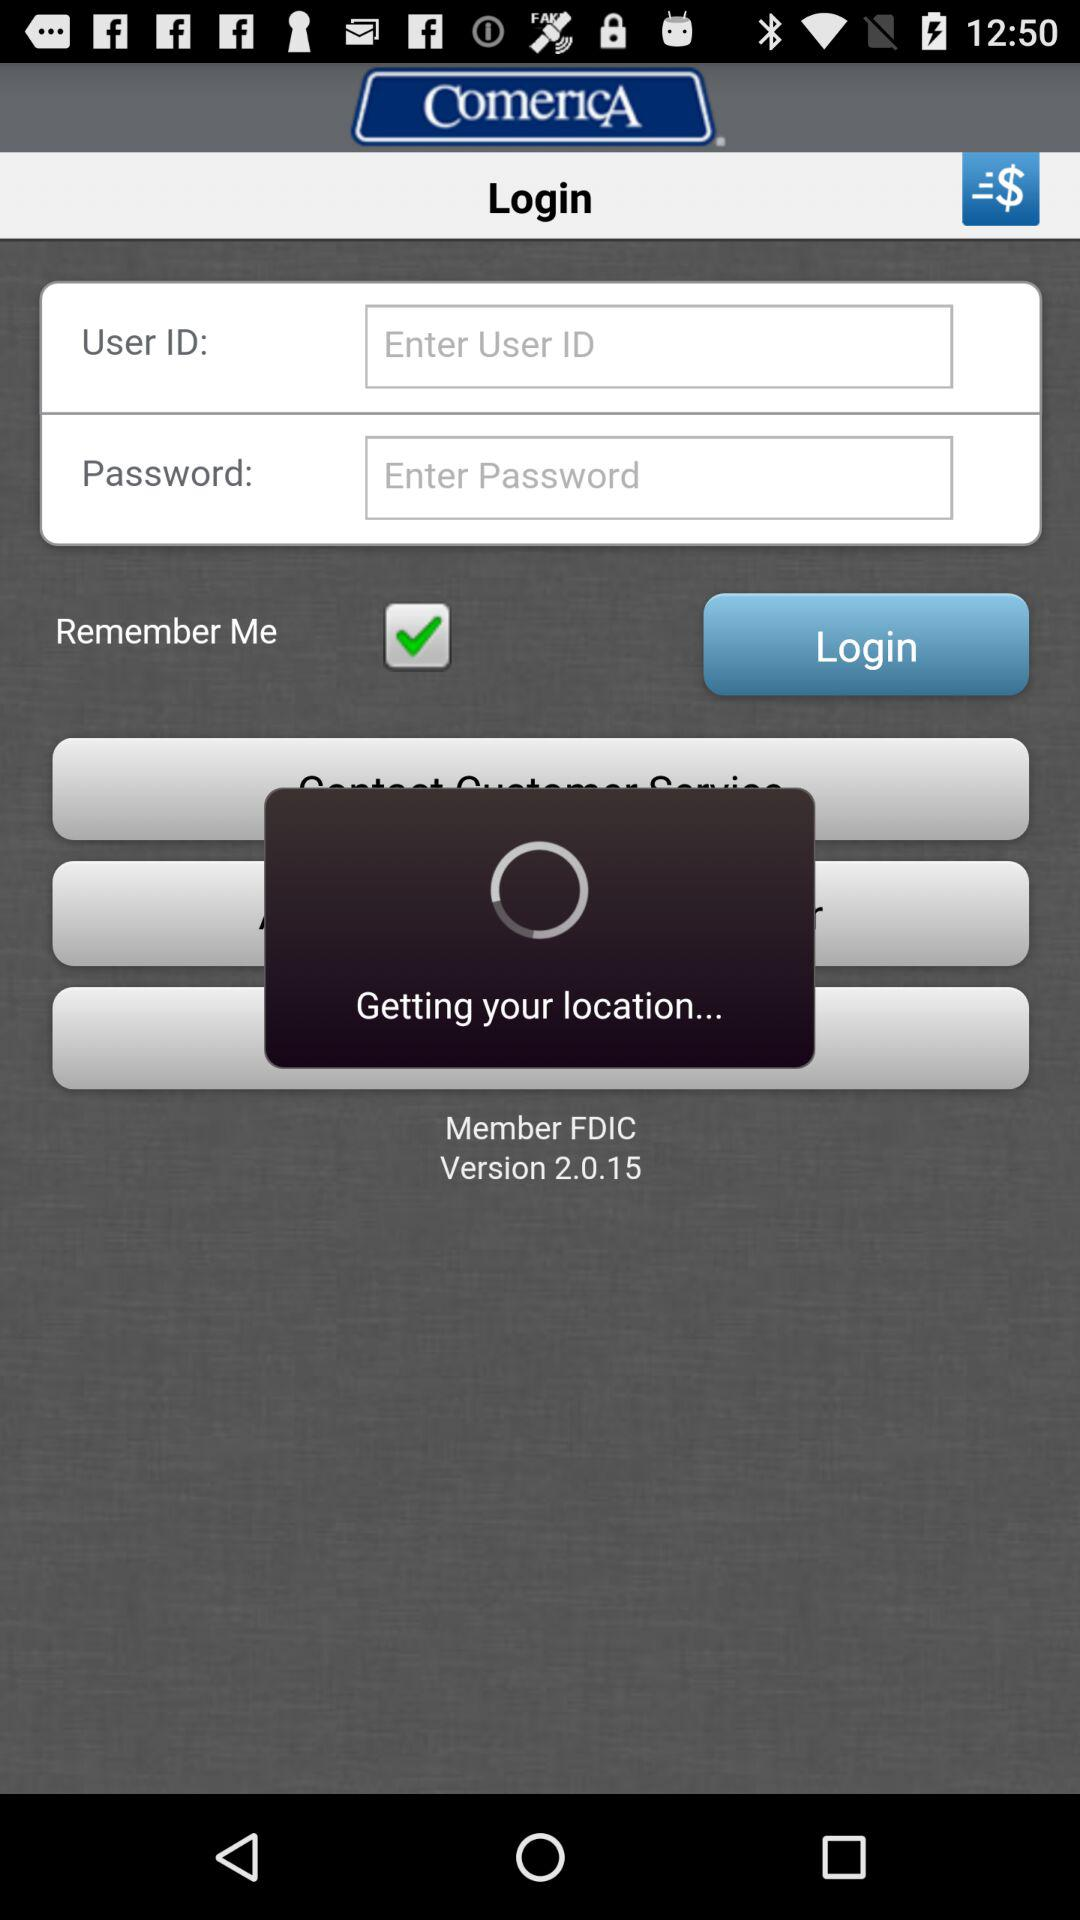How many contacts can be added in total?
When the provided information is insufficient, respond with <no answer>. <no answer> 